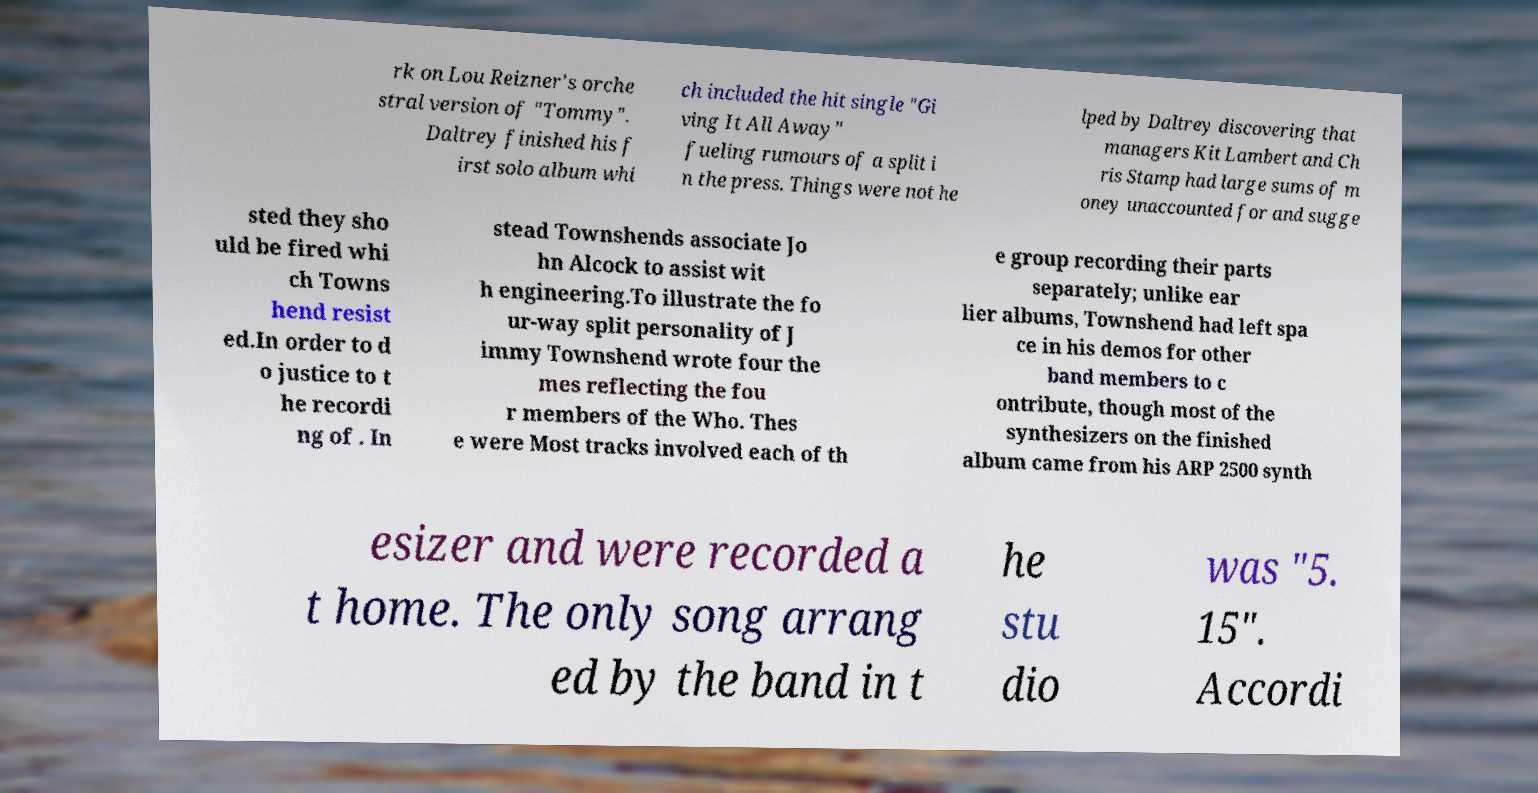Please identify and transcribe the text found in this image. rk on Lou Reizner's orche stral version of "Tommy". Daltrey finished his f irst solo album whi ch included the hit single "Gi ving It All Away" fueling rumours of a split i n the press. Things were not he lped by Daltrey discovering that managers Kit Lambert and Ch ris Stamp had large sums of m oney unaccounted for and sugge sted they sho uld be fired whi ch Towns hend resist ed.In order to d o justice to t he recordi ng of . In stead Townshends associate Jo hn Alcock to assist wit h engineering.To illustrate the fo ur-way split personality of J immy Townshend wrote four the mes reflecting the fou r members of the Who. Thes e were Most tracks involved each of th e group recording their parts separately; unlike ear lier albums, Townshend had left spa ce in his demos for other band members to c ontribute, though most of the synthesizers on the finished album came from his ARP 2500 synth esizer and were recorded a t home. The only song arrang ed by the band in t he stu dio was "5. 15". Accordi 